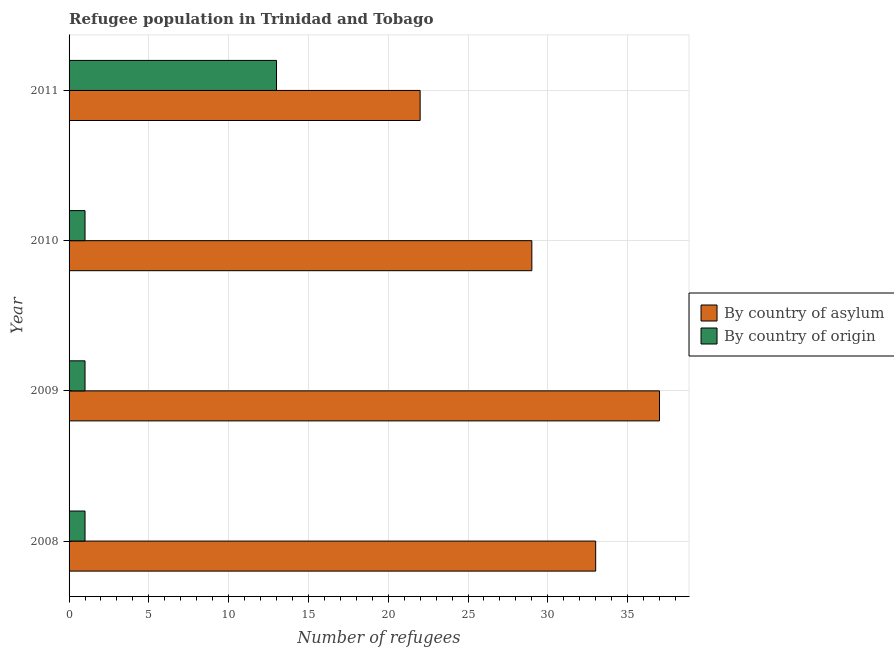How many different coloured bars are there?
Provide a short and direct response. 2. Are the number of bars per tick equal to the number of legend labels?
Give a very brief answer. Yes. Are the number of bars on each tick of the Y-axis equal?
Your response must be concise. Yes. How many bars are there on the 1st tick from the top?
Provide a succinct answer. 2. In how many cases, is the number of bars for a given year not equal to the number of legend labels?
Keep it short and to the point. 0. What is the number of refugees by country of origin in 2011?
Give a very brief answer. 13. Across all years, what is the maximum number of refugees by country of origin?
Your answer should be very brief. 13. Across all years, what is the minimum number of refugees by country of origin?
Ensure brevity in your answer.  1. In which year was the number of refugees by country of origin maximum?
Make the answer very short. 2011. What is the total number of refugees by country of origin in the graph?
Your response must be concise. 16. What is the difference between the number of refugees by country of asylum in 2009 and that in 2010?
Provide a short and direct response. 8. What is the difference between the number of refugees by country of origin in 2011 and the number of refugees by country of asylum in 2009?
Offer a terse response. -24. What is the average number of refugees by country of origin per year?
Your answer should be very brief. 4. In the year 2009, what is the difference between the number of refugees by country of asylum and number of refugees by country of origin?
Offer a very short reply. 36. In how many years, is the number of refugees by country of asylum greater than 34 ?
Provide a succinct answer. 1. What is the ratio of the number of refugees by country of asylum in 2010 to that in 2011?
Your response must be concise. 1.32. Is the number of refugees by country of origin in 2008 less than that in 2011?
Ensure brevity in your answer.  Yes. Is the difference between the number of refugees by country of origin in 2009 and 2010 greater than the difference between the number of refugees by country of asylum in 2009 and 2010?
Offer a terse response. No. What is the difference between the highest and the second highest number of refugees by country of origin?
Keep it short and to the point. 12. What is the difference between the highest and the lowest number of refugees by country of origin?
Give a very brief answer. 12. What does the 1st bar from the top in 2008 represents?
Offer a terse response. By country of origin. What does the 2nd bar from the bottom in 2008 represents?
Your answer should be compact. By country of origin. How many bars are there?
Your response must be concise. 8. Are all the bars in the graph horizontal?
Ensure brevity in your answer.  Yes. Does the graph contain grids?
Your answer should be very brief. Yes. How many legend labels are there?
Ensure brevity in your answer.  2. What is the title of the graph?
Your response must be concise. Refugee population in Trinidad and Tobago. Does "Old" appear as one of the legend labels in the graph?
Give a very brief answer. No. What is the label or title of the X-axis?
Offer a terse response. Number of refugees. What is the label or title of the Y-axis?
Give a very brief answer. Year. What is the Number of refugees in By country of asylum in 2008?
Make the answer very short. 33. What is the Number of refugees of By country of origin in 2008?
Offer a very short reply. 1. What is the Number of refugees of By country of origin in 2010?
Offer a very short reply. 1. What is the Number of refugees of By country of asylum in 2011?
Make the answer very short. 22. What is the Number of refugees of By country of origin in 2011?
Your answer should be very brief. 13. Across all years, what is the maximum Number of refugees of By country of asylum?
Offer a terse response. 37. Across all years, what is the maximum Number of refugees in By country of origin?
Provide a succinct answer. 13. What is the total Number of refugees in By country of asylum in the graph?
Make the answer very short. 121. What is the total Number of refugees in By country of origin in the graph?
Give a very brief answer. 16. What is the difference between the Number of refugees of By country of origin in 2008 and that in 2010?
Ensure brevity in your answer.  0. What is the difference between the Number of refugees in By country of origin in 2009 and that in 2010?
Your answer should be very brief. 0. What is the difference between the Number of refugees of By country of asylum in 2009 and that in 2011?
Ensure brevity in your answer.  15. What is the difference between the Number of refugees in By country of origin in 2009 and that in 2011?
Offer a very short reply. -12. What is the difference between the Number of refugees in By country of asylum in 2008 and the Number of refugees in By country of origin in 2009?
Provide a short and direct response. 32. What is the difference between the Number of refugees in By country of asylum in 2009 and the Number of refugees in By country of origin in 2010?
Offer a terse response. 36. What is the difference between the Number of refugees of By country of asylum in 2009 and the Number of refugees of By country of origin in 2011?
Your answer should be very brief. 24. What is the difference between the Number of refugees of By country of asylum in 2010 and the Number of refugees of By country of origin in 2011?
Your response must be concise. 16. What is the average Number of refugees in By country of asylum per year?
Keep it short and to the point. 30.25. What is the average Number of refugees of By country of origin per year?
Your response must be concise. 4. In the year 2010, what is the difference between the Number of refugees in By country of asylum and Number of refugees in By country of origin?
Offer a very short reply. 28. In the year 2011, what is the difference between the Number of refugees of By country of asylum and Number of refugees of By country of origin?
Provide a succinct answer. 9. What is the ratio of the Number of refugees in By country of asylum in 2008 to that in 2009?
Make the answer very short. 0.89. What is the ratio of the Number of refugees in By country of origin in 2008 to that in 2009?
Make the answer very short. 1. What is the ratio of the Number of refugees of By country of asylum in 2008 to that in 2010?
Provide a succinct answer. 1.14. What is the ratio of the Number of refugees in By country of origin in 2008 to that in 2011?
Give a very brief answer. 0.08. What is the ratio of the Number of refugees of By country of asylum in 2009 to that in 2010?
Ensure brevity in your answer.  1.28. What is the ratio of the Number of refugees of By country of origin in 2009 to that in 2010?
Provide a short and direct response. 1. What is the ratio of the Number of refugees of By country of asylum in 2009 to that in 2011?
Give a very brief answer. 1.68. What is the ratio of the Number of refugees of By country of origin in 2009 to that in 2011?
Keep it short and to the point. 0.08. What is the ratio of the Number of refugees of By country of asylum in 2010 to that in 2011?
Your response must be concise. 1.32. What is the ratio of the Number of refugees of By country of origin in 2010 to that in 2011?
Offer a very short reply. 0.08. What is the difference between the highest and the second highest Number of refugees of By country of asylum?
Your answer should be very brief. 4. What is the difference between the highest and the second highest Number of refugees in By country of origin?
Your answer should be very brief. 12. What is the difference between the highest and the lowest Number of refugees in By country of asylum?
Offer a terse response. 15. What is the difference between the highest and the lowest Number of refugees in By country of origin?
Your response must be concise. 12. 